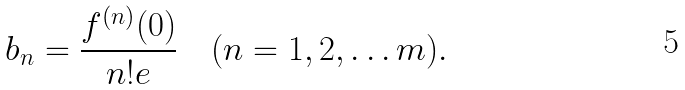Convert formula to latex. <formula><loc_0><loc_0><loc_500><loc_500>b _ { n } = \frac { f ^ { ( n ) } ( 0 ) } { n ! e } \quad ( n = 1 , 2 , \dots m ) .</formula> 